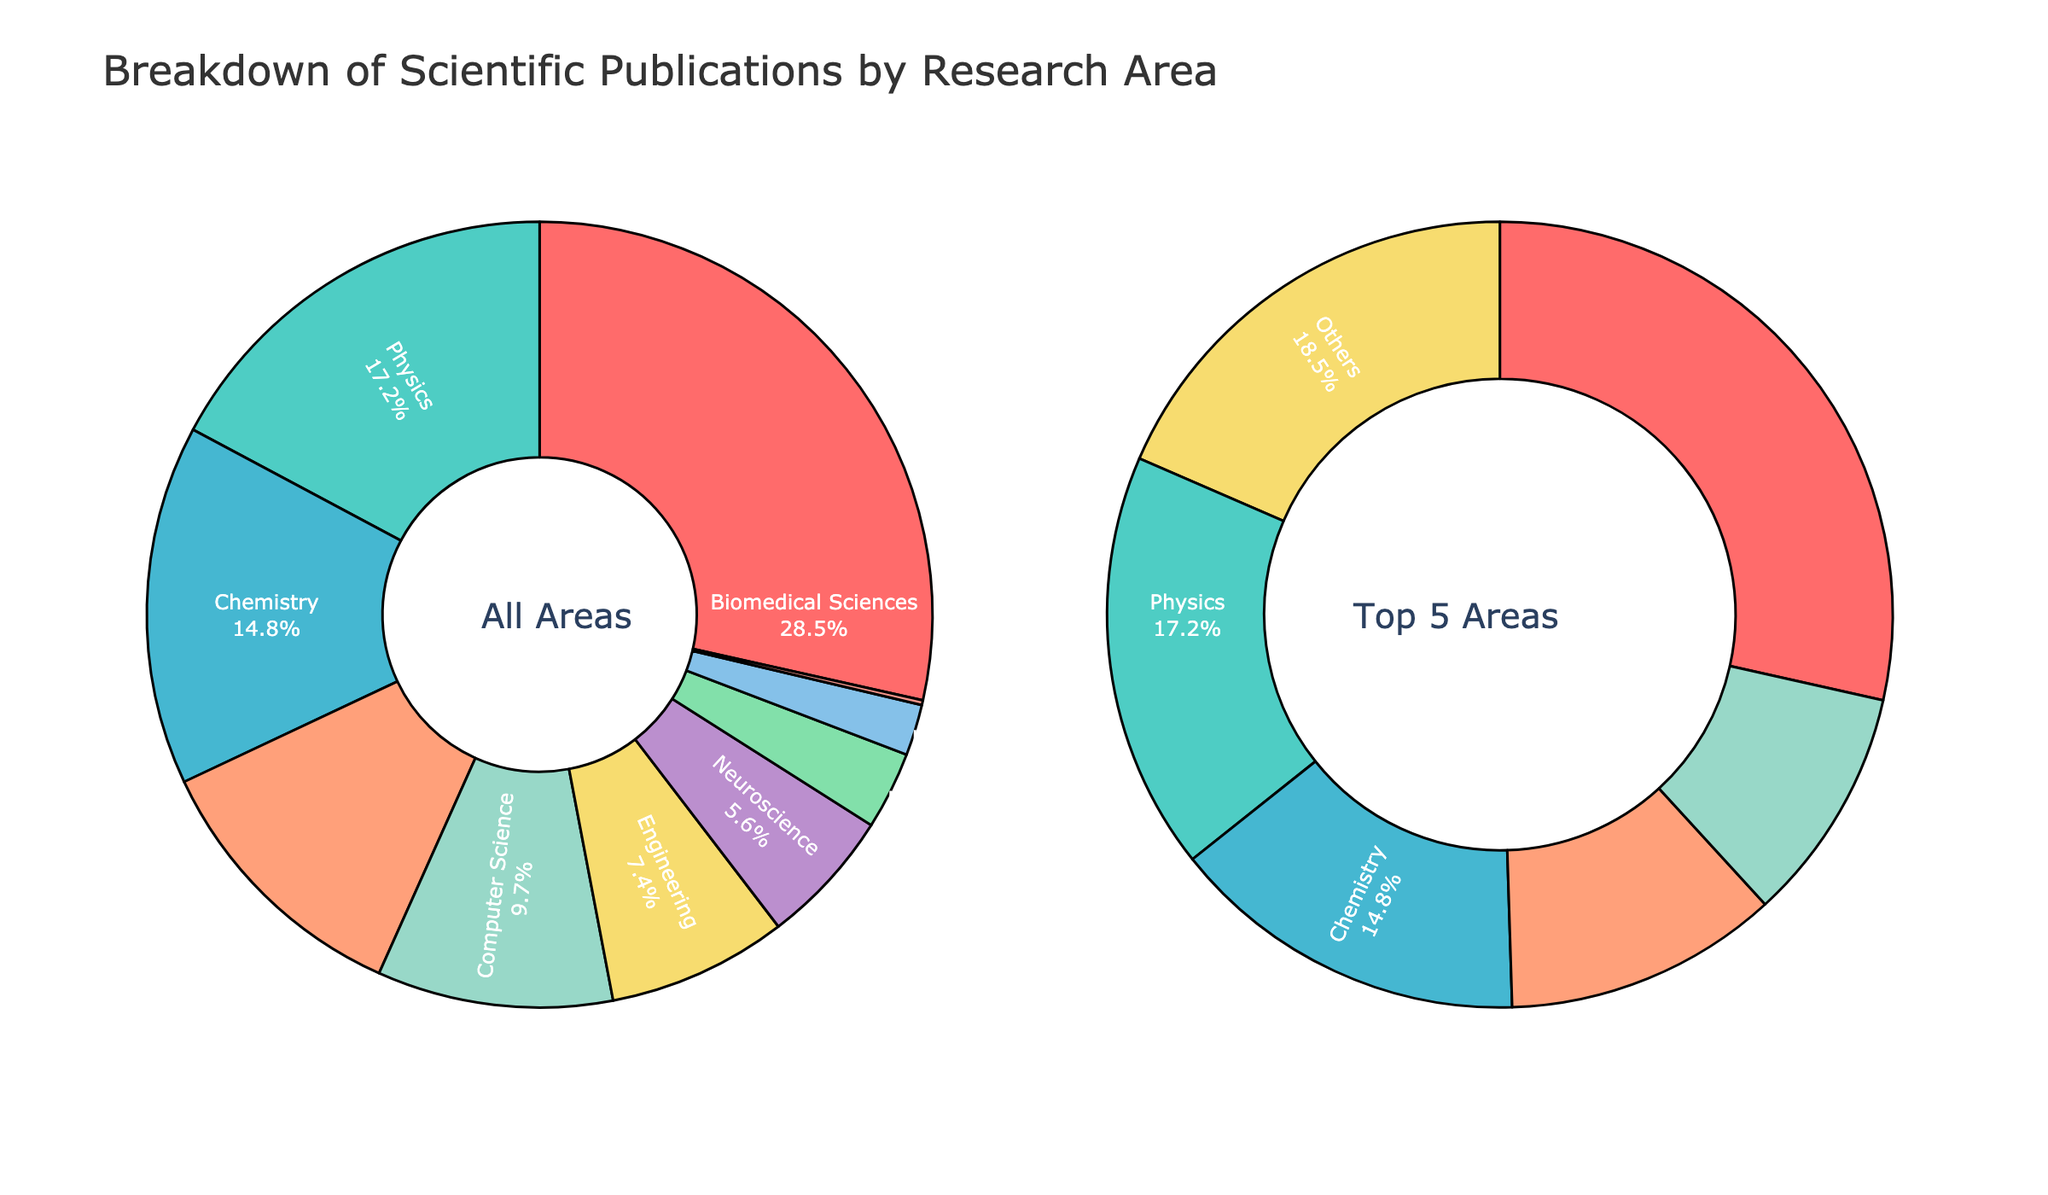What percentage of the total publications are in Biomedical Sciences? The pie chart shows the percentage of publications in different research areas. For Biomedical Sciences, the percentage is directly labeled as 28.5%.
Answer: 28.5% Which research area has the lowest percentage of publications? By examining the smallest segment in the pie chart, Genetics is identified as the research area with the smallest percentage, labeled as 0.2%.
Answer: Genetics How does the percentage of publications in Physics compare to those in Chemistry? Physics accounts for 17.2% of the publications while Chemistry accounts for 14.8%. Comparing these values shows that Physics has a greater percentage than Chemistry.
Answer: Physics has a greater percentage What is the combined percentage of publications in Environmental Sciences and Computer Science? Environmental Sciences is labeled as 11.3%, and Computer Science as 9.7%. Adding these percentages: 11.3% + 9.7% = 21%.
Answer: 21% What is the total percentage of publications in the top 5 research areas? The top 5 areas are Biomedical Sciences (28.5%), Physics (17.2%), Chemistry (14.8%), Environmental Sciences (11.3%), and Computer Science (9.7%). Summing these values gives the total: 28.5 + 17.2 + 14.8 + 11.3 + 9.7 = 81.5%.
Answer: 81.5% What colors represent the sections for Biomedical Sciences and Astronomy? The visual attributes of the pie chart show Biomedical Sciences in a red shade and Astronomy in a light blue shade.
Answer: Red and Light Blue How many research areas make up less than 10% each of the total publications? By examining the labeled segments, Computer Science (9.7%), Engineering (7.4%), Neuroscience (5.6%), Materials Science (3.2%), Astronomy (2.1%), and Genetics (0.2%) make up less than 10% each. This is a total of 6 areas.
Answer: 6 What is the percentage difference between Biomedical Sciences and Neuroscience publications? Biomedical Sciences has 28.5%, and Neuroscience has 5.6%. The difference is calculated as 28.5% - 5.6% = 22.9%.
Answer: 22.9% What percentage of publications are in areas other than the top 5 research areas? The total percentage for the top 5 areas is 81.5%. Subtracting this from 100% gives the publications outside the top 5: 100% - 81.5% = 18.5%.
Answer: 18.5% If Engineering and Materials Science were combined into one category, what would be their total percentage? Engineering accounts for 7.4% and Materials Science for 3.2%. Combined, they would account for 7.4% + 3.2% = 10.6%.
Answer: 10.6% 